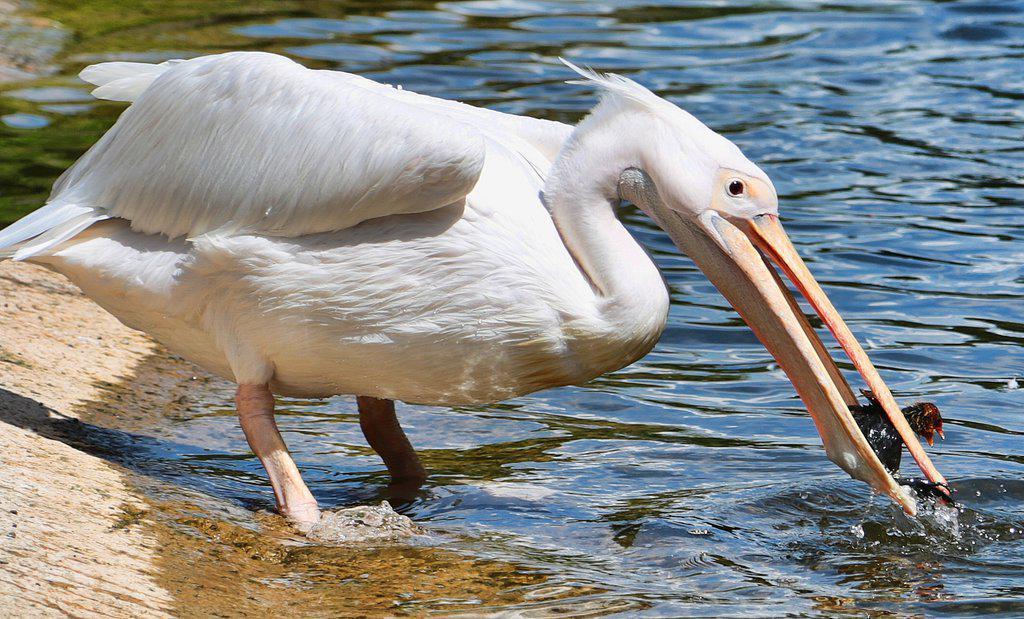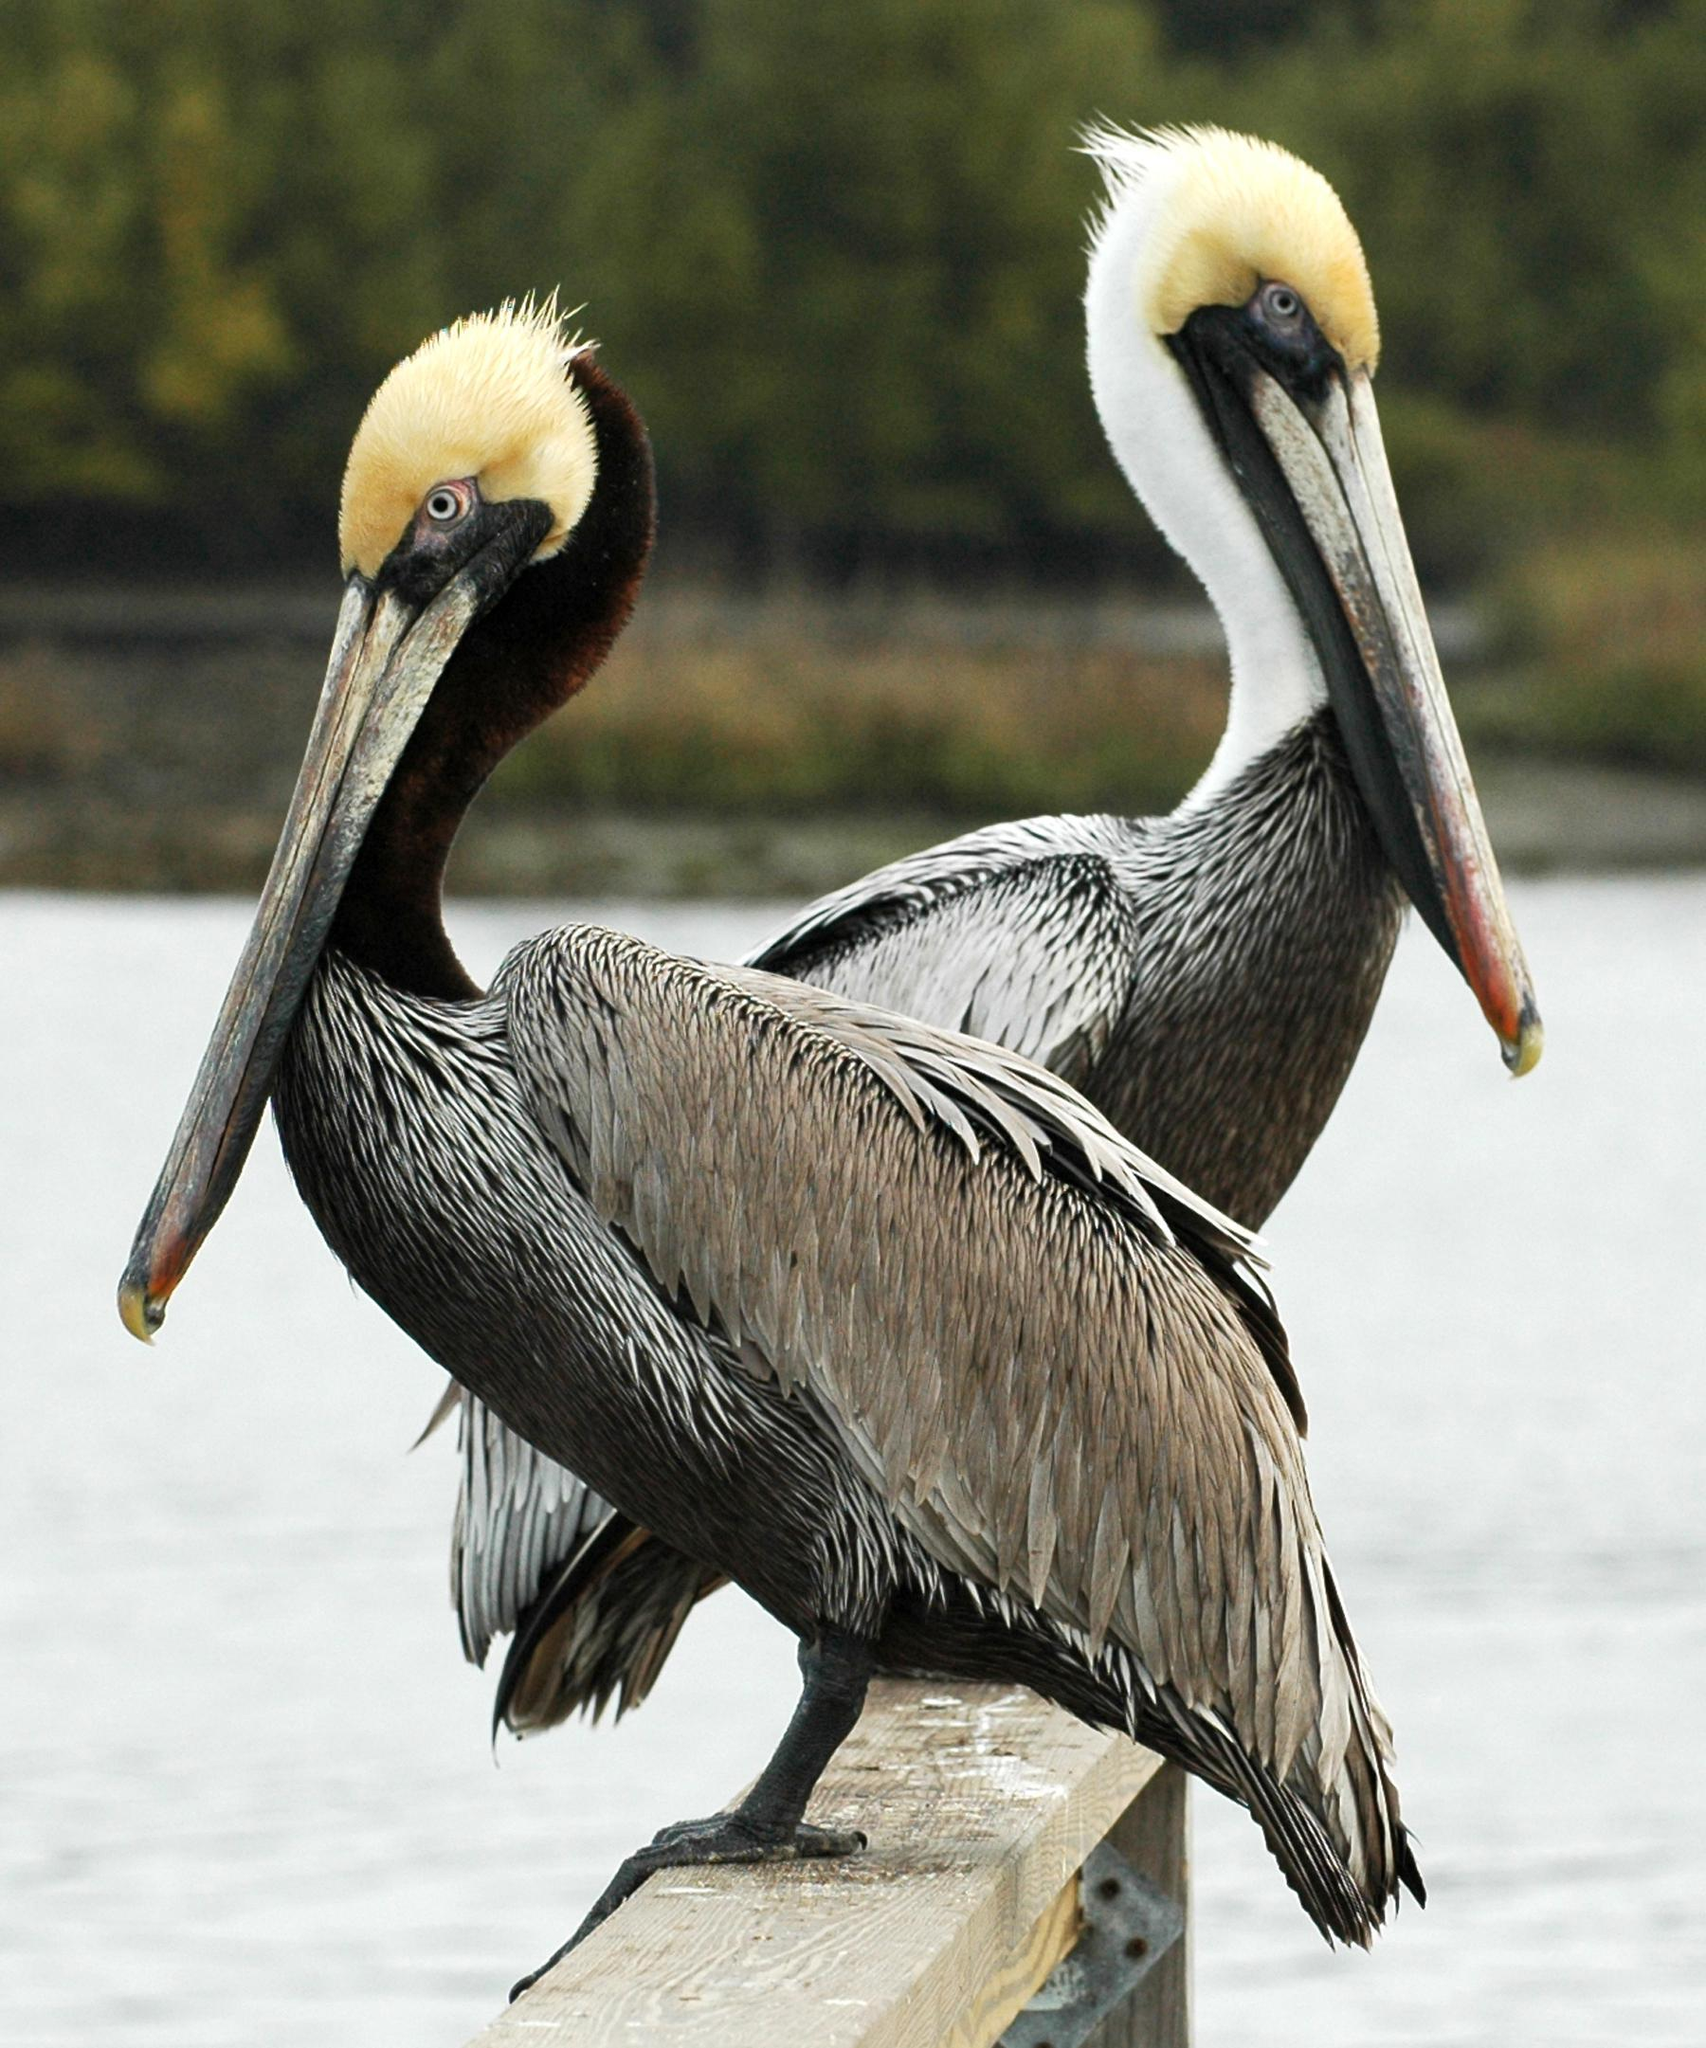The first image is the image on the left, the second image is the image on the right. Given the left and right images, does the statement "There a single bird with black and white feathers facing left." hold true? Answer yes or no. No. The first image is the image on the left, the second image is the image on the right. For the images shown, is this caption "The bird in the left image has a fish in it's beak." true? Answer yes or no. Yes. 